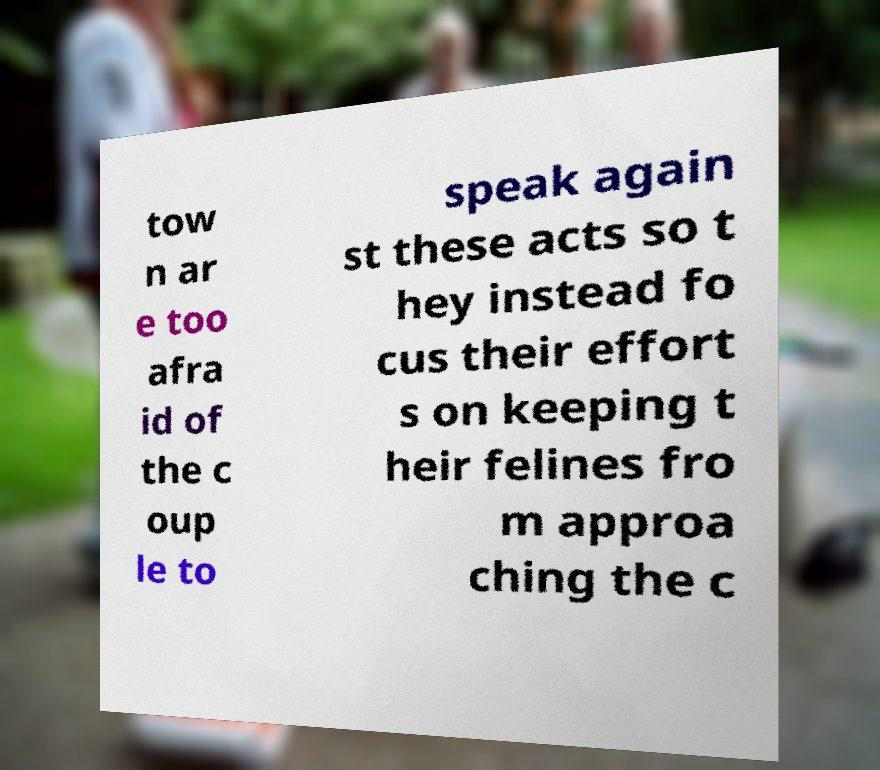What messages or text are displayed in this image? I need them in a readable, typed format. tow n ar e too afra id of the c oup le to speak again st these acts so t hey instead fo cus their effort s on keeping t heir felines fro m approa ching the c 